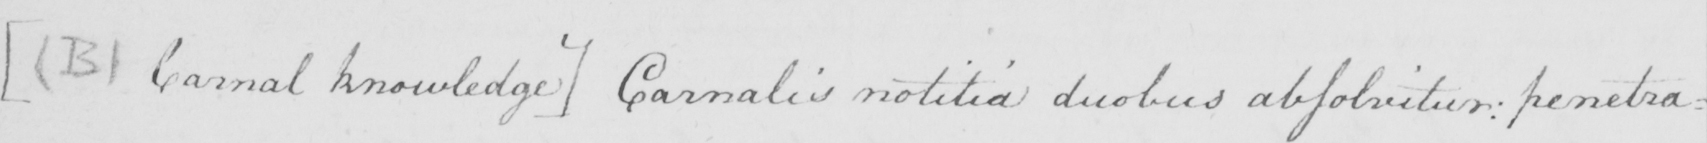What is written in this line of handwriting? [  ( B )  Carnal knowledge ]  Carnalis notilia duobus absolvitur :  penetra= 